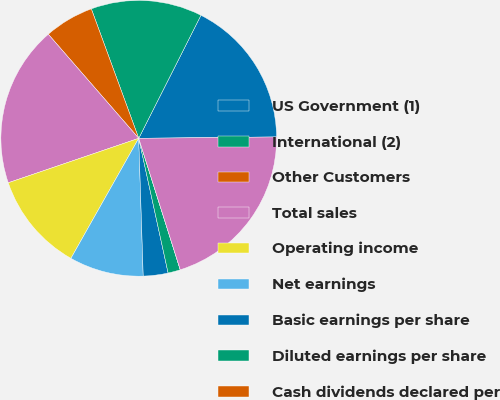<chart> <loc_0><loc_0><loc_500><loc_500><pie_chart><fcel>US Government (1)<fcel>International (2)<fcel>Other Customers<fcel>Total sales<fcel>Operating income<fcel>Net earnings<fcel>Basic earnings per share<fcel>Diluted earnings per share<fcel>Cash dividends declared per<fcel>Total assets<nl><fcel>17.39%<fcel>13.04%<fcel>5.8%<fcel>18.84%<fcel>11.59%<fcel>8.7%<fcel>2.9%<fcel>1.45%<fcel>0.0%<fcel>20.29%<nl></chart> 